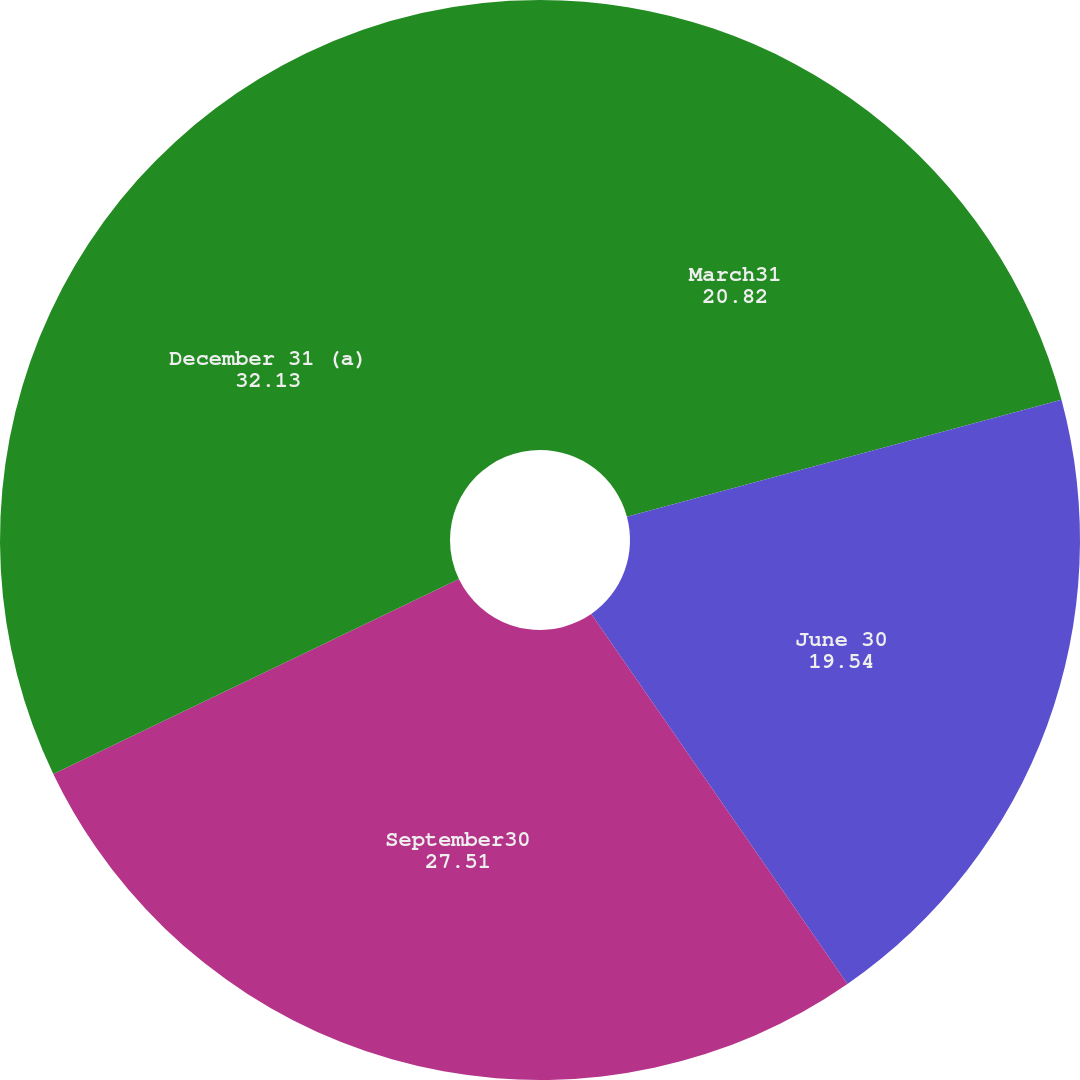Convert chart. <chart><loc_0><loc_0><loc_500><loc_500><pie_chart><fcel>March31<fcel>June 30<fcel>September30<fcel>December 31 (a)<nl><fcel>20.82%<fcel>19.54%<fcel>27.51%<fcel>32.13%<nl></chart> 